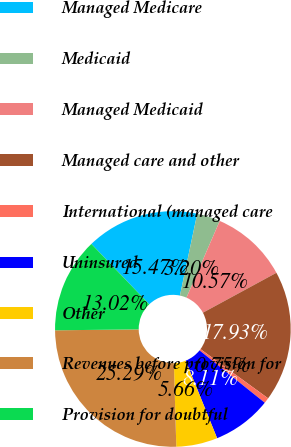Convert chart to OTSL. <chart><loc_0><loc_0><loc_500><loc_500><pie_chart><fcel>Managed Medicare<fcel>Medicaid<fcel>Managed Medicaid<fcel>Managed care and other<fcel>International (managed care<fcel>Uninsured<fcel>Other<fcel>Revenues before provision for<fcel>Provision for doubtful<nl><fcel>15.47%<fcel>3.2%<fcel>10.57%<fcel>17.93%<fcel>0.75%<fcel>8.11%<fcel>5.66%<fcel>25.29%<fcel>13.02%<nl></chart> 